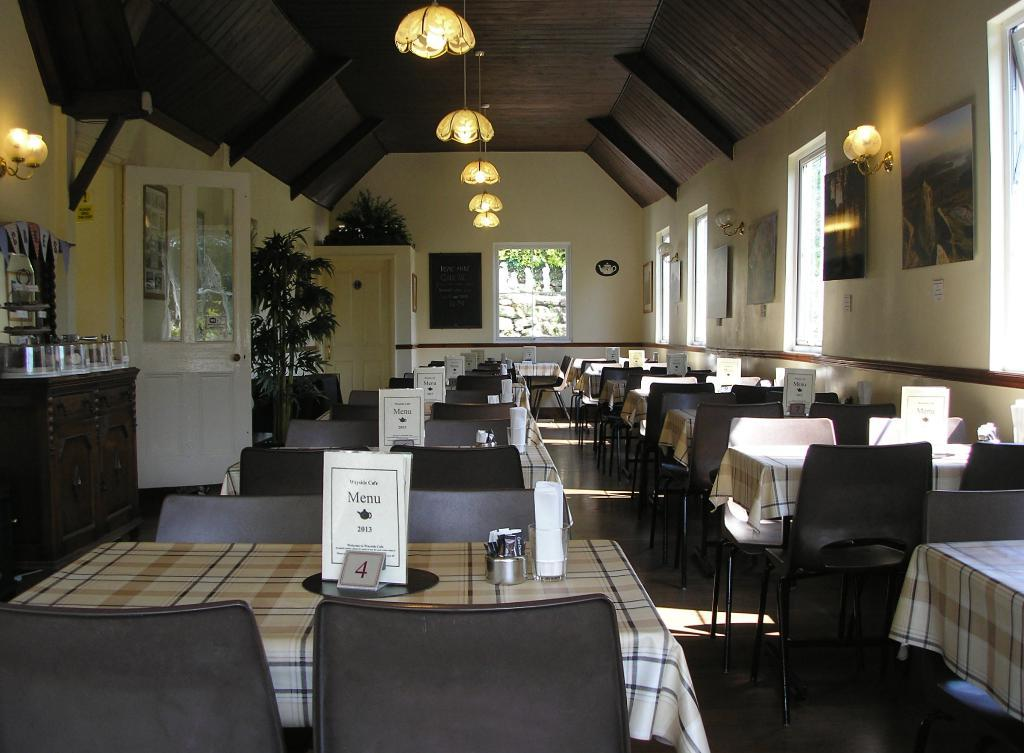What type of furniture is present in the image? There are tables and chairs in the image. What objects can be seen on the tables? Cards and boards are visible on the tables in the image. What type of lighting is present in the image? There are lights in the image. What type of greenery is present in the image? There are house plants in the image. What is attached to the wall in the image? There are frames attached to the wall in the image. What other objects can be seen in the image? There are some objects in the image. Can you tell me how many jellyfish are swimming in the soup in the image? There is no soup or jellyfish present in the image. What type of insect is crawling on the cards in the image? There are no insects visible on the cards in the image. 